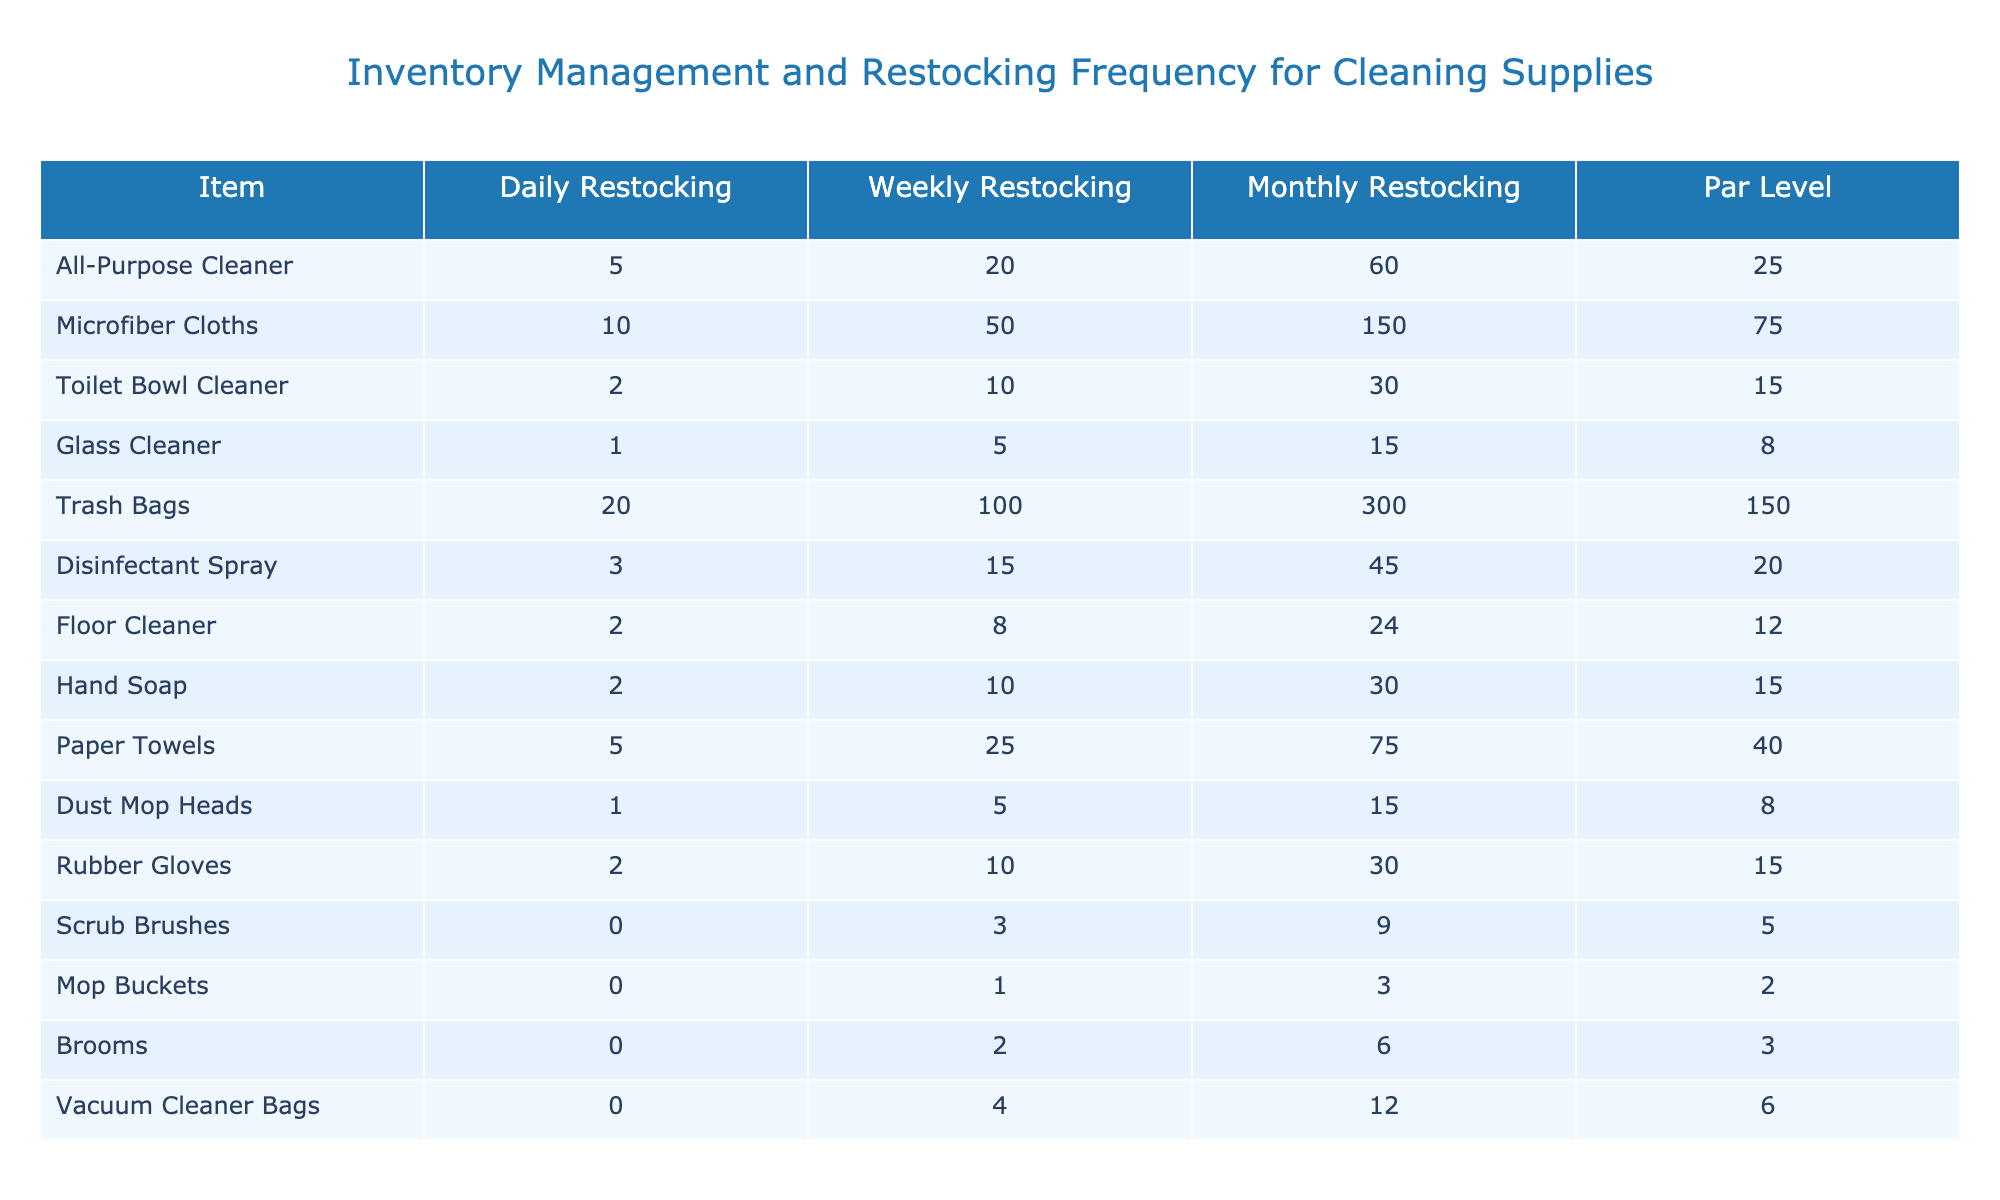What is the par level for all-purpose cleaner? The table directly shows that the par level for the all-purpose cleaner is 25.
Answer: 25 How many microfiber cloths would you need for a monthly restocking? The table indicates that monthly restocking requires 150 microfiber cloths.
Answer: 150 Which cleaning supply has the highest daily restocking requirement? By comparing the daily restocking values, trash bags have the highest requirement at 20.
Answer: Trash Bags Is the par level for toilet bowl cleaner greater than 10? The table shows the par level for toilet bowl cleaner is 15, which is greater than 10.
Answer: Yes What is the total number of items that require weekly restocking of more than 20? The items with weekly restocking more than 20 are: microfiber cloths (50), trash bags (100), and paper towels (25). Summing these gives 50 + 100 + 25 = 175.
Answer: 175 How many items have a par level lower than or equal to 5? The table lists scrub brushes (5) and mop buckets (2) as having a par level of 5 or lower. Therefore, there are 2 items.
Answer: 2 What is the difference between the daily restocking for trash bags and glass cleaner? The daily restocking for trash bags is 20, and for glass cleaner, it is 1. The difference is calculated as 20 - 1 = 19.
Answer: 19 If I need to restock floor cleaner weekly and monthly, how many would I need in total? The weekly requirement is 8, and the monthly requirement is 24. Adding these together gives 8 + 24 = 32.
Answer: 32 Which item has the lowest par level and what is it? The par level of mop buckets is 2, which is the lowest among all items listed.
Answer: Mop Buckets How many total cleaning supplies are being tracked in this inventory list? The table lists 14 different cleaning supplies, hence the total is 14.
Answer: 14 What is the average monthly restocking amount across all items? The monthly restocking values are 60, 150, 30, 15, 300, 45, 24, 30, 75, 15, 30, 9, 3, 12. Summing these gives 60 + 150 + 30 + 15 + 300 + 45 + 24 + 30 + 75 + 15 + 30 + 9 + 3 + 12 =  792. Then dividing by 14 (the number of items) gives an average of 56.57.
Answer: 56.57 How many items require daily restocking of more than 5? The items requiring daily restocking of more than 5 are microfiber cloths (10), trash bags (20), and paper towels (5). This results in a total of 4 items: all-purpose cleaner, microfiber cloths, and trash bags.
Answer: 4 